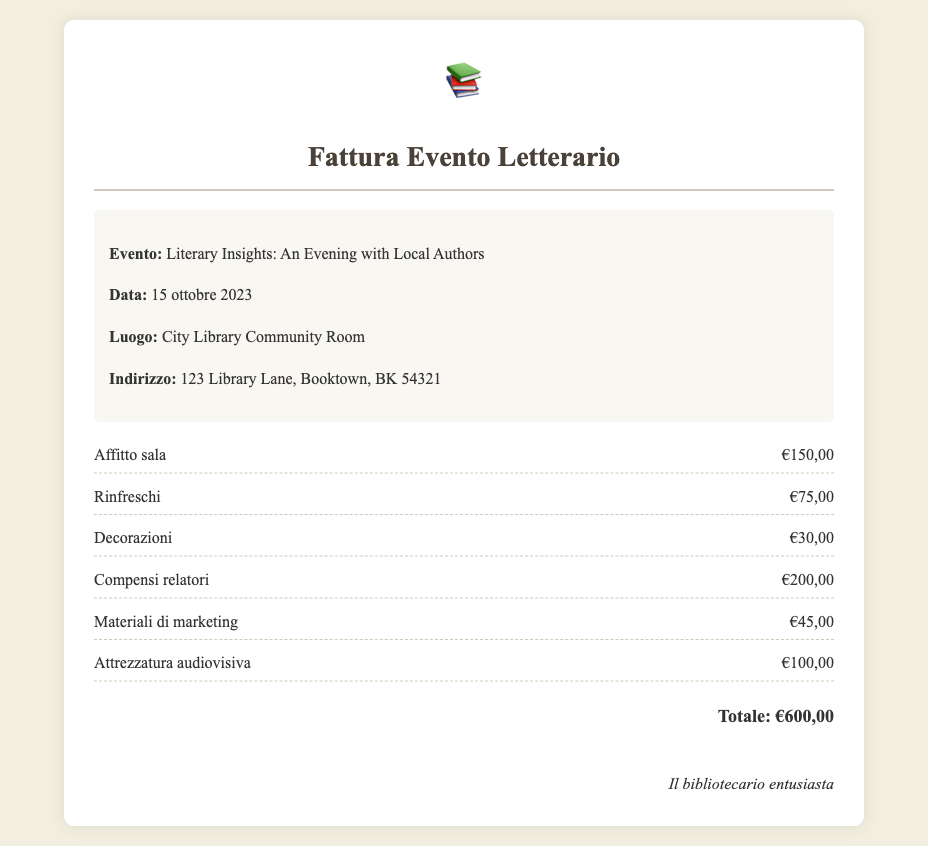Qual è il nome dell'evento? Il nome dell'evento è indicato nella sezione delle dettagli dell'evento.
Answer: Literary Insights: An Evening with Local Authors Qual è la data dell'evento? La data si trova nella sezione delle dettagli dell'evento.
Answer: 15 ottobre 2023 Dove si è svolto l'evento? L'indirizzo dell'evento è specificato nei dettagli dell'evento.
Answer: City Library Community Room Quanto è costato l'affitto della sala? Il costo dell'affitto della sala è riportato nella sezione delle spese.
Answer: €150,00 Chi ha firmato la fattura? Il nome della persona che ha firmato la fattura è fornito alla fine del documento.
Answer: Il bibliotecario entusiasta Qual è il costo totale delle spese? Il totale è riportato in fondo alla lista delle spese.
Answer: €600,00 Quanti euro sono stati spesi per i rinfreschi? Il costo dei rinfreschi è elencato nelle spese dettagliate.
Answer: €75,00 Qual è stato il compenso per i relatori? Il compenso per i relatori è specificato nella lista delle spese.
Answer: €200,00 Qual è il costo per le decorazioni? Il costo per le decorazioni è elencato nel documento delle spese.
Answer: €30,00 